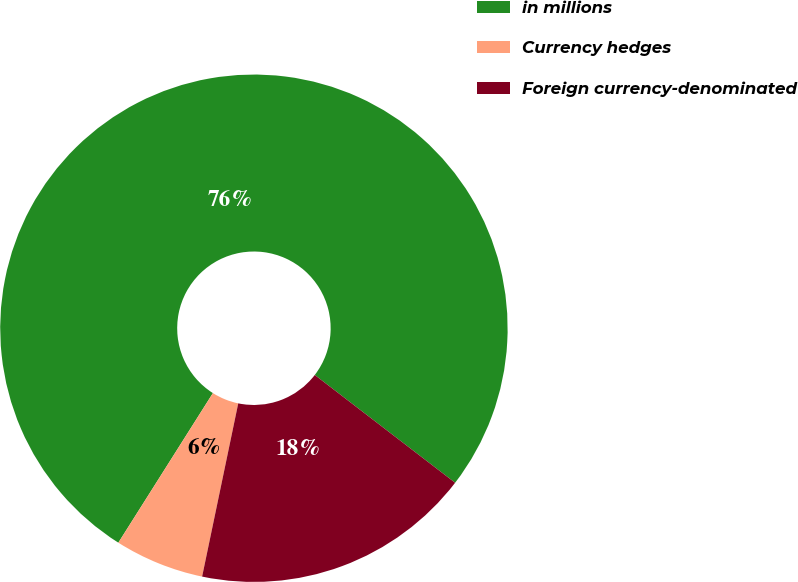Convert chart to OTSL. <chart><loc_0><loc_0><loc_500><loc_500><pie_chart><fcel>in millions<fcel>Currency hedges<fcel>Foreign currency-denominated<nl><fcel>76.45%<fcel>5.7%<fcel>17.85%<nl></chart> 